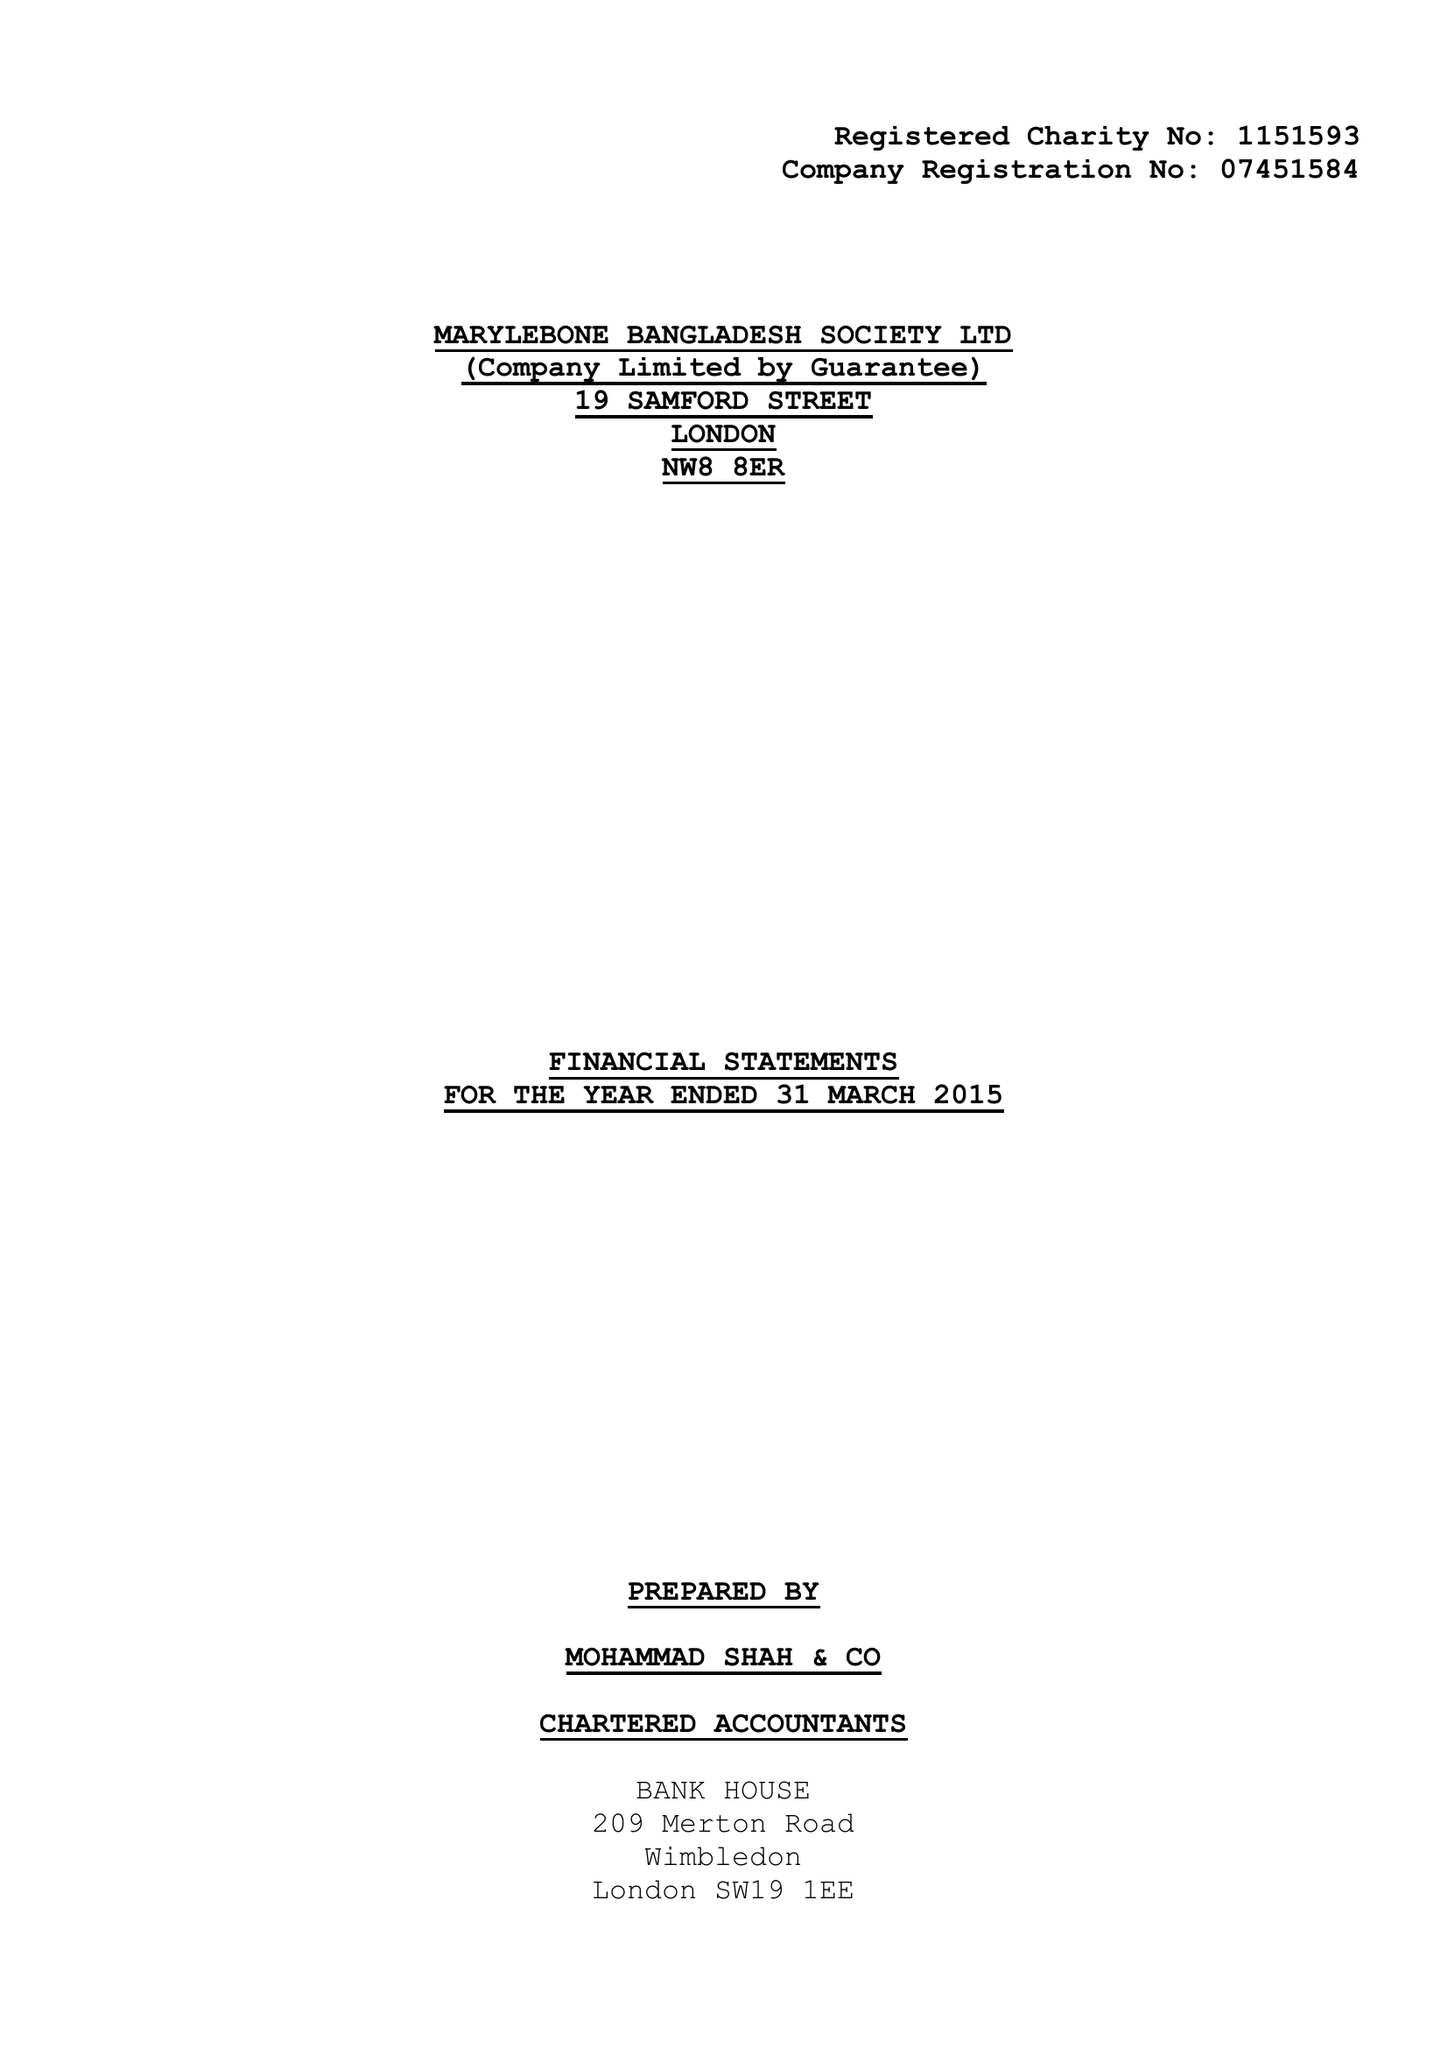What is the value for the charity_number?
Answer the question using a single word or phrase. 1151593 